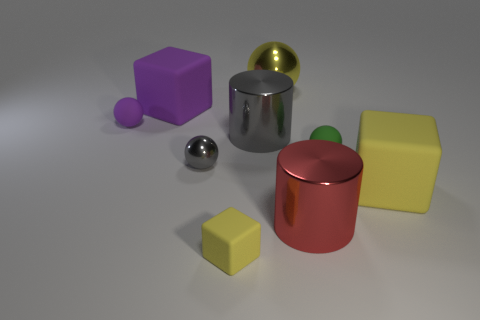Add 1 big brown shiny cubes. How many objects exist? 10 Subtract all cubes. How many objects are left? 6 Subtract all large red objects. Subtract all big metal things. How many objects are left? 5 Add 3 big yellow matte blocks. How many big yellow matte blocks are left? 4 Add 3 tiny purple cubes. How many tiny purple cubes exist? 3 Subtract 1 purple blocks. How many objects are left? 8 